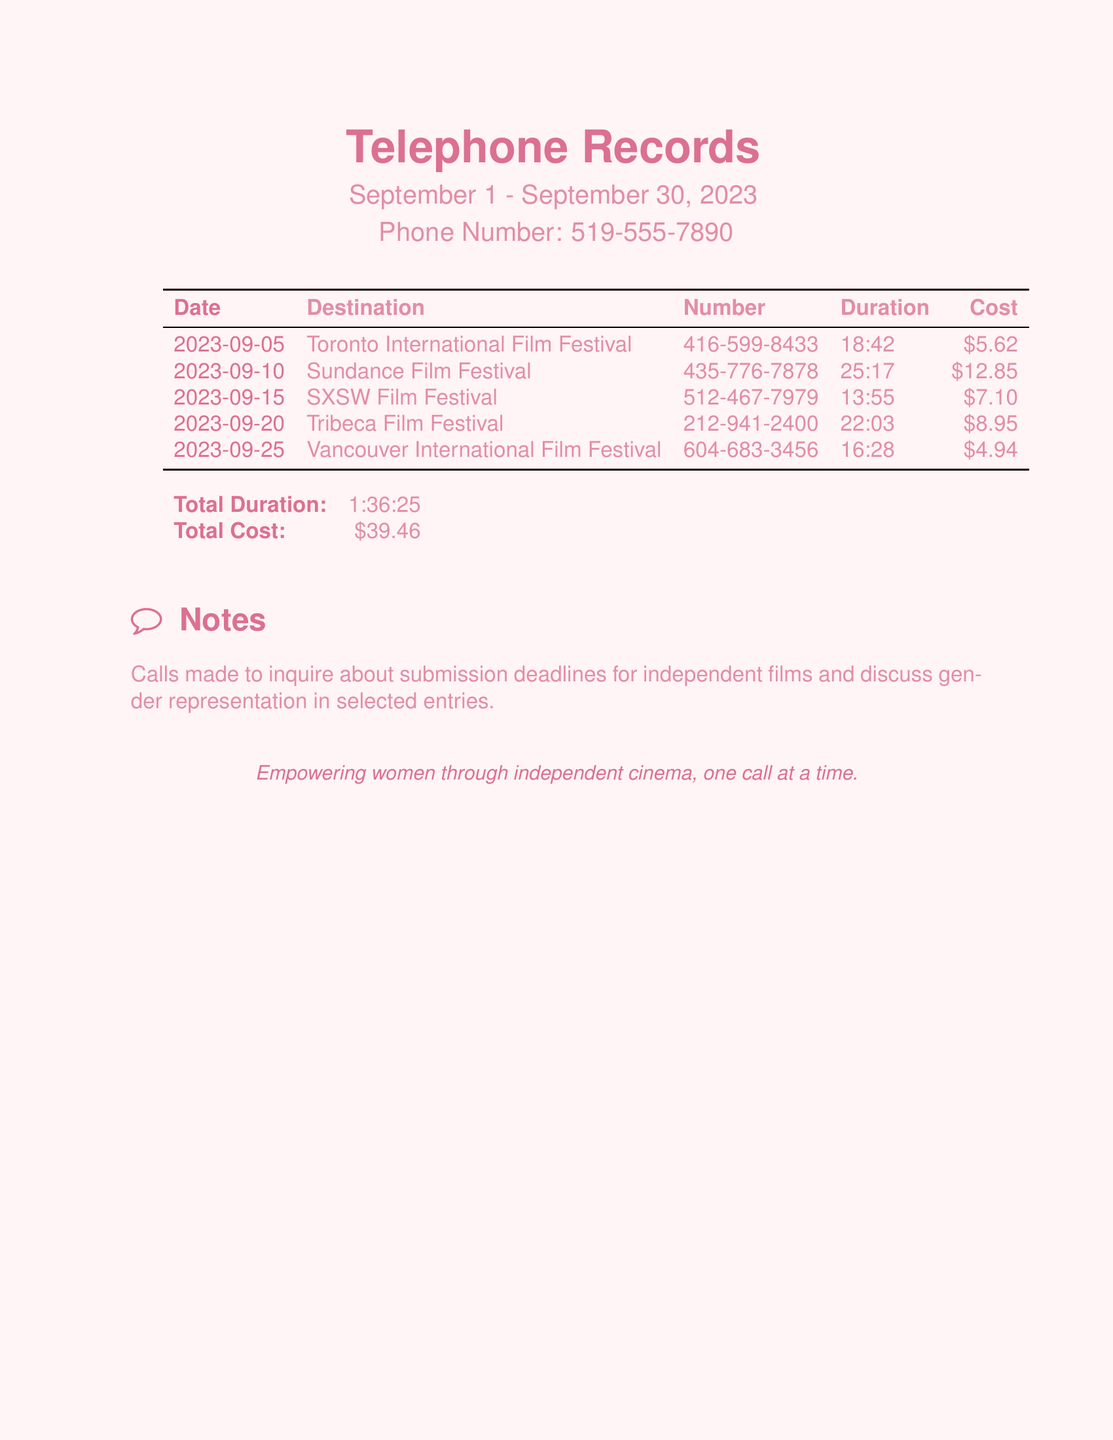What is the total cost of the calls? The total cost is listed at the bottom of the document, calculated from the costs of individual calls.
Answer: $39.46 How long was the call to the Toronto International Film Festival? The duration of the call is noted in the duration column next to the corresponding destination.
Answer: 18:42 Which festival had the longest call duration? By comparing the durations of all calls, the longest duration can be identified.
Answer: Sundance Film Festival What date was the call to SXSW Film Festival made? The date for the call is specified in the first column next to the festival name.
Answer: 2023-09-15 What is the purpose of the calls as noted in the document? The notes section explains the purpose of the calls made during this time period.
Answer: Inquire about submission deadlines and discuss gender representation How many total minutes were spent on calls? The total duration can be converted from the format given in the document to minutes.
Answer: 96 minutes Which city hosted the Tribeca Film Festival? The city for the Tribeca Film Festival is mentioned in the destination column.
Answer: New York What is the phone number for the Vancouver International Film Festival? The phone number is listed next to the corresponding festival in the document.
Answer: 604-683-3456 